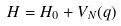<formula> <loc_0><loc_0><loc_500><loc_500>H = H _ { 0 } + V _ { N } ( q )</formula> 